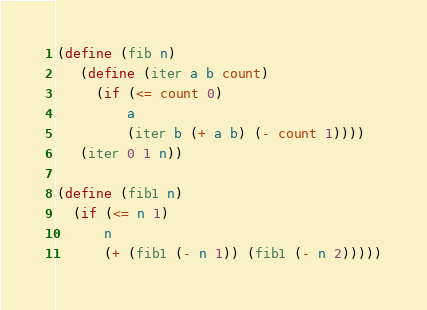<code> <loc_0><loc_0><loc_500><loc_500><_Scheme_>(define (fib n)
   (define (iter a b count)
     (if (<= count 0)
         a
         (iter b (+ a b) (- count 1))))
   (iter 0 1 n))

(define (fib1 n)
  (if (<= n 1)
      n
      (+ (fib1 (- n 1)) (fib1 (- n 2)))))
</code> 